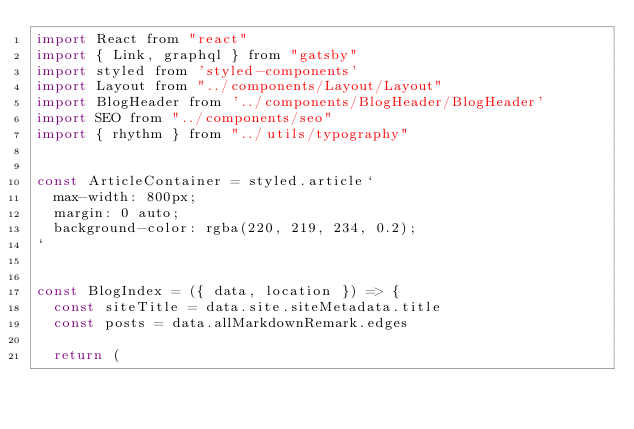Convert code to text. <code><loc_0><loc_0><loc_500><loc_500><_JavaScript_>import React from "react"
import { Link, graphql } from "gatsby"
import styled from 'styled-components'
import Layout from "../components/Layout/Layout"
import BlogHeader from '../components/BlogHeader/BlogHeader'
import SEO from "../components/seo"
import { rhythm } from "../utils/typography"


const ArticleContainer = styled.article`
  max-width: 800px;
  margin: 0 auto;
  background-color: rgba(220, 219, 234, 0.2);
`


const BlogIndex = ({ data, location }) => {
  const siteTitle = data.site.siteMetadata.title
  const posts = data.allMarkdownRemark.edges

  return (</code> 